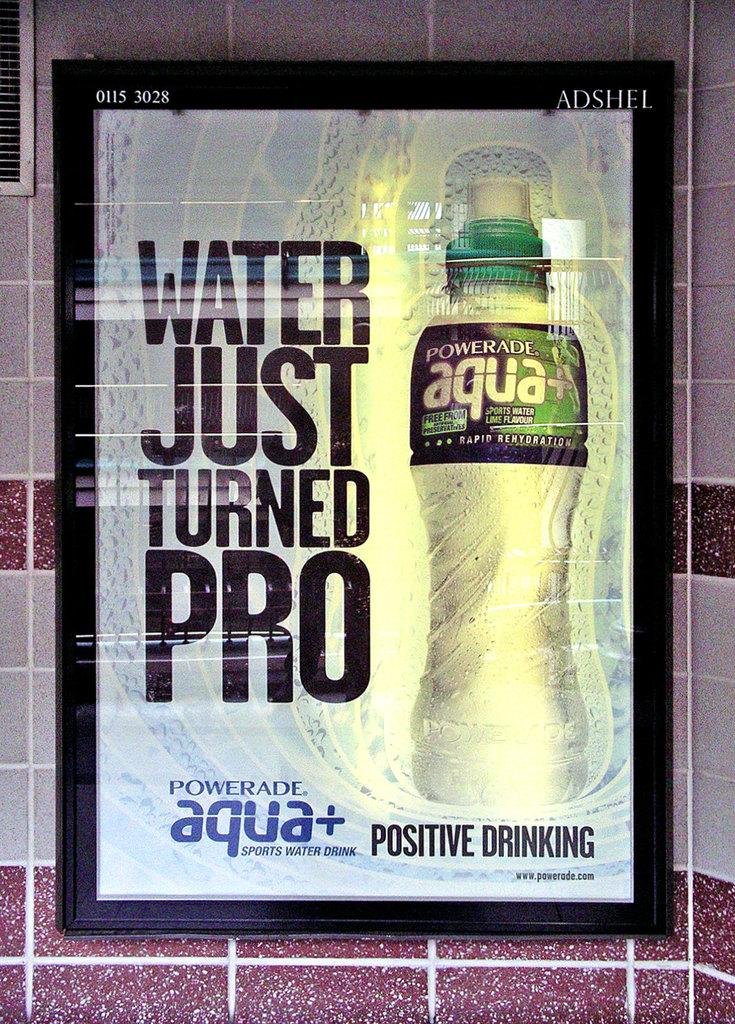<image>
Summarize the visual content of the image. An advertisement for Powerade Aqua on a title wall. 